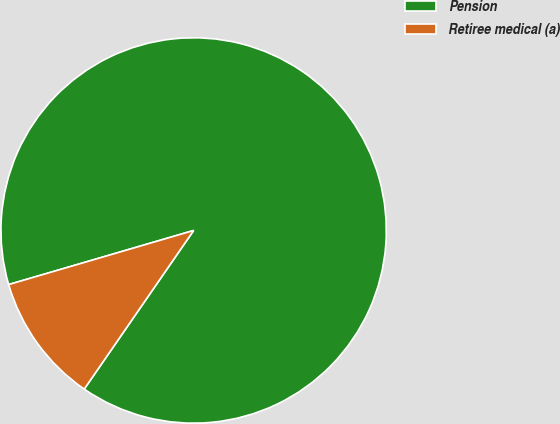Convert chart. <chart><loc_0><loc_0><loc_500><loc_500><pie_chart><fcel>Pension<fcel>Retiree medical (a)<nl><fcel>89.14%<fcel>10.86%<nl></chart> 